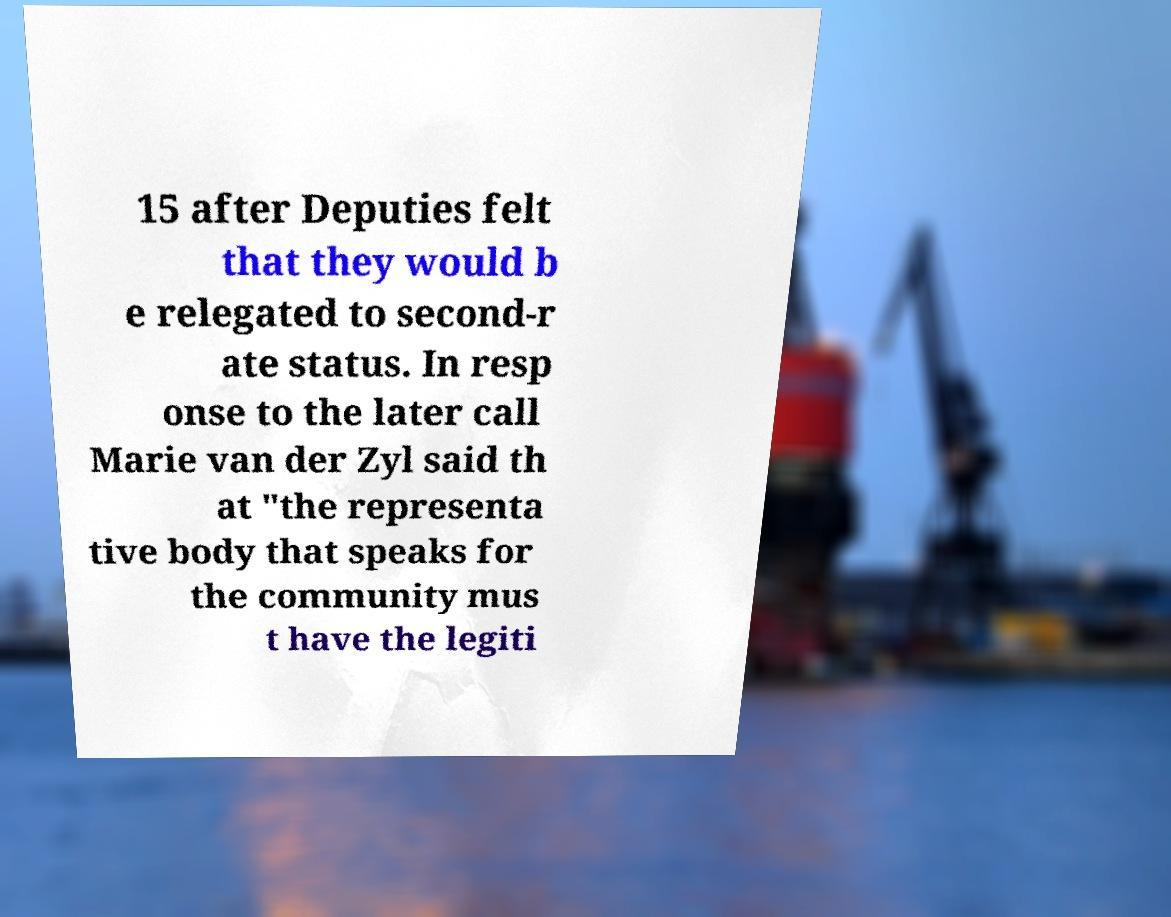For documentation purposes, I need the text within this image transcribed. Could you provide that? 15 after Deputies felt that they would b e relegated to second-r ate status. In resp onse to the later call Marie van der Zyl said th at "the representa tive body that speaks for the community mus t have the legiti 